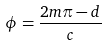Convert formula to latex. <formula><loc_0><loc_0><loc_500><loc_500>\phi = \frac { 2 m \pi - d } { c }</formula> 